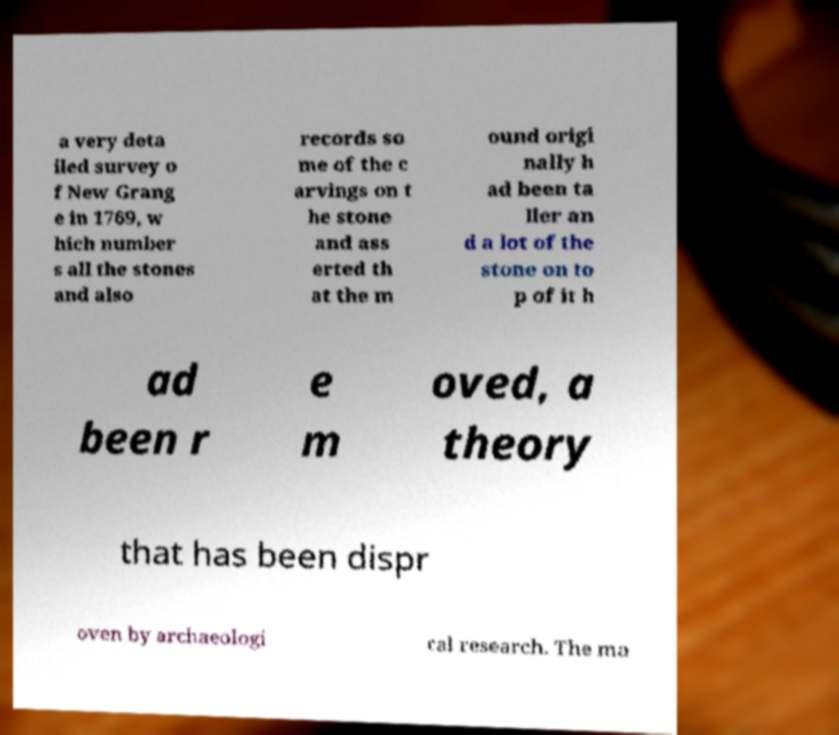Could you assist in decoding the text presented in this image and type it out clearly? a very deta iled survey o f New Grang e in 1769, w hich number s all the stones and also records so me of the c arvings on t he stone and ass erted th at the m ound origi nally h ad been ta ller an d a lot of the stone on to p of it h ad been r e m oved, a theory that has been dispr oven by archaeologi cal research. The ma 